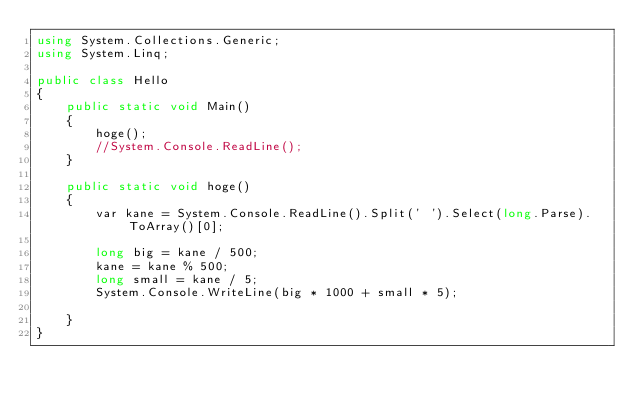Convert code to text. <code><loc_0><loc_0><loc_500><loc_500><_C#_>using System.Collections.Generic;
using System.Linq;

public class Hello
{
    public static void Main()
    {
        hoge();
        //System.Console.ReadLine();
    }

    public static void hoge()
    {
        var kane = System.Console.ReadLine().Split(' ').Select(long.Parse).ToArray()[0];

        long big = kane / 500;
        kane = kane % 500;
        long small = kane / 5;
        System.Console.WriteLine(big * 1000 + small * 5);

    }
}</code> 